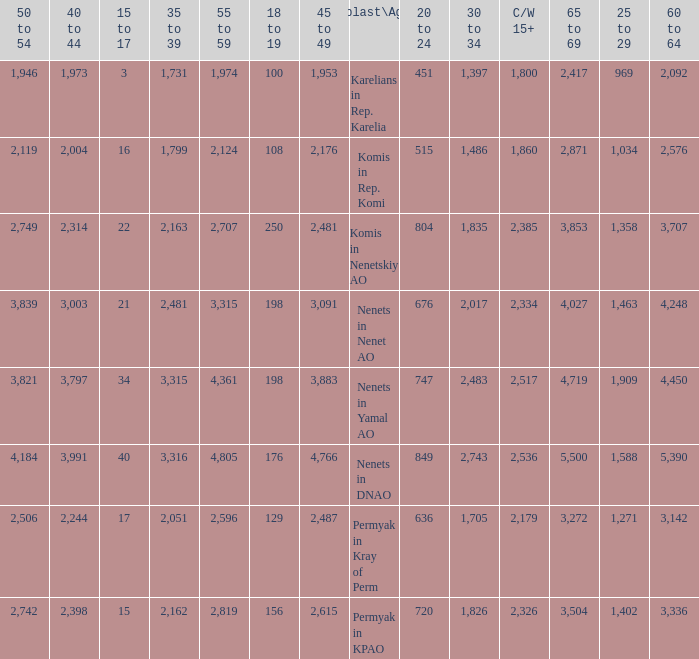Parse the full table. {'header': ['50 to 54', '40 to 44', '15 to 17', '35 to 39', '55 to 59', '18 to 19', '45 to 49', 'Oblast\\Age', '20 to 24', '30 to 34', 'C/W 15+', '65 to 69', '25 to 29', '60 to 64'], 'rows': [['1,946', '1,973', '3', '1,731', '1,974', '100', '1,953', 'Karelians in Rep. Karelia', '451', '1,397', '1,800', '2,417', '969', '2,092'], ['2,119', '2,004', '16', '1,799', '2,124', '108', '2,176', 'Komis in Rep. Komi', '515', '1,486', '1,860', '2,871', '1,034', '2,576'], ['2,749', '2,314', '22', '2,163', '2,707', '250', '2,481', 'Komis in Nenetskiy AO', '804', '1,835', '2,385', '3,853', '1,358', '3,707'], ['3,839', '3,003', '21', '2,481', '3,315', '198', '3,091', 'Nenets in Nenet AO', '676', '2,017', '2,334', '4,027', '1,463', '4,248'], ['3,821', '3,797', '34', '3,315', '4,361', '198', '3,883', 'Nenets in Yamal AO', '747', '2,483', '2,517', '4,719', '1,909', '4,450'], ['4,184', '3,991', '40', '3,316', '4,805', '176', '4,766', 'Nenets in DNAO', '849', '2,743', '2,536', '5,500', '1,588', '5,390'], ['2,506', '2,244', '17', '2,051', '2,596', '129', '2,487', 'Permyak in Kray of Perm', '636', '1,705', '2,179', '3,272', '1,271', '3,142'], ['2,742', '2,398', '15', '2,162', '2,819', '156', '2,615', 'Permyak in KPAO', '720', '1,826', '2,326', '3,504', '1,402', '3,336']]} What is the mean 55 to 59 when the C/W 15+ is greater than 2,385, and the 30 to 34 is 2,483, and the 35 to 39 is greater than 3,315? None. 